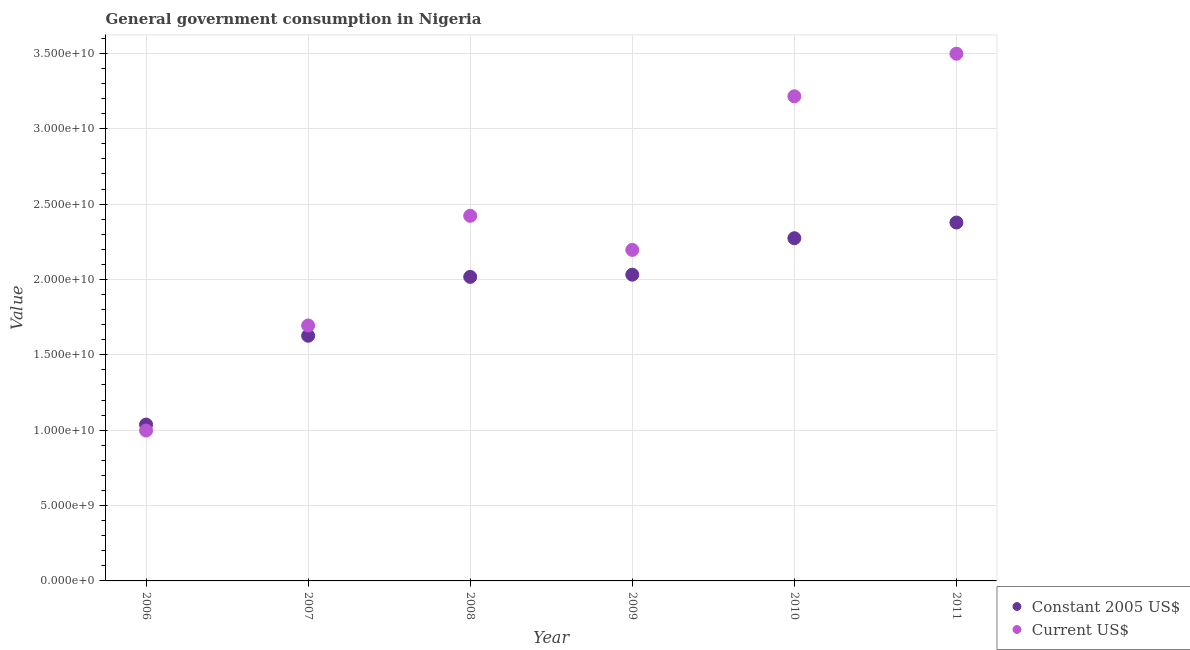Is the number of dotlines equal to the number of legend labels?
Ensure brevity in your answer.  Yes. What is the value consumed in constant 2005 us$ in 2008?
Give a very brief answer. 2.02e+1. Across all years, what is the maximum value consumed in constant 2005 us$?
Keep it short and to the point. 2.38e+1. Across all years, what is the minimum value consumed in constant 2005 us$?
Give a very brief answer. 1.04e+1. In which year was the value consumed in current us$ minimum?
Your answer should be compact. 2006. What is the total value consumed in current us$ in the graph?
Your response must be concise. 1.40e+11. What is the difference between the value consumed in constant 2005 us$ in 2009 and that in 2011?
Provide a succinct answer. -3.46e+09. What is the difference between the value consumed in current us$ in 2006 and the value consumed in constant 2005 us$ in 2009?
Offer a very short reply. -1.03e+1. What is the average value consumed in current us$ per year?
Offer a terse response. 2.34e+1. In the year 2008, what is the difference between the value consumed in constant 2005 us$ and value consumed in current us$?
Your answer should be compact. -4.05e+09. In how many years, is the value consumed in current us$ greater than 22000000000?
Your answer should be very brief. 3. What is the ratio of the value consumed in current us$ in 2006 to that in 2008?
Offer a very short reply. 0.41. Is the difference between the value consumed in constant 2005 us$ in 2009 and 2011 greater than the difference between the value consumed in current us$ in 2009 and 2011?
Give a very brief answer. Yes. What is the difference between the highest and the second highest value consumed in constant 2005 us$?
Make the answer very short. 1.04e+09. What is the difference between the highest and the lowest value consumed in constant 2005 us$?
Your response must be concise. 1.34e+1. Is the value consumed in constant 2005 us$ strictly greater than the value consumed in current us$ over the years?
Keep it short and to the point. No. Is the value consumed in constant 2005 us$ strictly less than the value consumed in current us$ over the years?
Your answer should be very brief. No. Are the values on the major ticks of Y-axis written in scientific E-notation?
Offer a very short reply. Yes. Does the graph contain any zero values?
Your response must be concise. No. What is the title of the graph?
Make the answer very short. General government consumption in Nigeria. Does "Research and Development" appear as one of the legend labels in the graph?
Make the answer very short. No. What is the label or title of the Y-axis?
Keep it short and to the point. Value. What is the Value of Constant 2005 US$ in 2006?
Your response must be concise. 1.04e+1. What is the Value in Current US$ in 2006?
Your answer should be compact. 9.98e+09. What is the Value in Constant 2005 US$ in 2007?
Your answer should be very brief. 1.63e+1. What is the Value of Current US$ in 2007?
Provide a short and direct response. 1.69e+1. What is the Value of Constant 2005 US$ in 2008?
Make the answer very short. 2.02e+1. What is the Value in Current US$ in 2008?
Your answer should be very brief. 2.42e+1. What is the Value in Constant 2005 US$ in 2009?
Keep it short and to the point. 2.03e+1. What is the Value in Current US$ in 2009?
Make the answer very short. 2.20e+1. What is the Value in Constant 2005 US$ in 2010?
Offer a terse response. 2.27e+1. What is the Value in Current US$ in 2010?
Give a very brief answer. 3.22e+1. What is the Value in Constant 2005 US$ in 2011?
Your answer should be very brief. 2.38e+1. What is the Value of Current US$ in 2011?
Provide a short and direct response. 3.50e+1. Across all years, what is the maximum Value in Constant 2005 US$?
Provide a succinct answer. 2.38e+1. Across all years, what is the maximum Value of Current US$?
Give a very brief answer. 3.50e+1. Across all years, what is the minimum Value of Constant 2005 US$?
Keep it short and to the point. 1.04e+1. Across all years, what is the minimum Value of Current US$?
Offer a terse response. 9.98e+09. What is the total Value in Constant 2005 US$ in the graph?
Provide a short and direct response. 1.14e+11. What is the total Value of Current US$ in the graph?
Make the answer very short. 1.40e+11. What is the difference between the Value of Constant 2005 US$ in 2006 and that in 2007?
Your answer should be very brief. -5.89e+09. What is the difference between the Value of Current US$ in 2006 and that in 2007?
Give a very brief answer. -6.97e+09. What is the difference between the Value in Constant 2005 US$ in 2006 and that in 2008?
Provide a short and direct response. -9.80e+09. What is the difference between the Value in Current US$ in 2006 and that in 2008?
Ensure brevity in your answer.  -1.42e+1. What is the difference between the Value of Constant 2005 US$ in 2006 and that in 2009?
Ensure brevity in your answer.  -9.94e+09. What is the difference between the Value in Current US$ in 2006 and that in 2009?
Make the answer very short. -1.20e+1. What is the difference between the Value of Constant 2005 US$ in 2006 and that in 2010?
Your answer should be compact. -1.24e+1. What is the difference between the Value in Current US$ in 2006 and that in 2010?
Your answer should be compact. -2.22e+1. What is the difference between the Value in Constant 2005 US$ in 2006 and that in 2011?
Offer a terse response. -1.34e+1. What is the difference between the Value in Current US$ in 2006 and that in 2011?
Offer a terse response. -2.50e+1. What is the difference between the Value of Constant 2005 US$ in 2007 and that in 2008?
Your answer should be very brief. -3.91e+09. What is the difference between the Value of Current US$ in 2007 and that in 2008?
Offer a terse response. -7.28e+09. What is the difference between the Value in Constant 2005 US$ in 2007 and that in 2009?
Offer a terse response. -4.05e+09. What is the difference between the Value in Current US$ in 2007 and that in 2009?
Ensure brevity in your answer.  -5.02e+09. What is the difference between the Value in Constant 2005 US$ in 2007 and that in 2010?
Offer a very short reply. -6.47e+09. What is the difference between the Value of Current US$ in 2007 and that in 2010?
Give a very brief answer. -1.52e+1. What is the difference between the Value of Constant 2005 US$ in 2007 and that in 2011?
Provide a short and direct response. -7.51e+09. What is the difference between the Value of Current US$ in 2007 and that in 2011?
Your response must be concise. -1.80e+1. What is the difference between the Value in Constant 2005 US$ in 2008 and that in 2009?
Provide a short and direct response. -1.46e+08. What is the difference between the Value in Current US$ in 2008 and that in 2009?
Give a very brief answer. 2.26e+09. What is the difference between the Value in Constant 2005 US$ in 2008 and that in 2010?
Provide a short and direct response. -2.56e+09. What is the difference between the Value of Current US$ in 2008 and that in 2010?
Your answer should be compact. -7.93e+09. What is the difference between the Value in Constant 2005 US$ in 2008 and that in 2011?
Offer a terse response. -3.60e+09. What is the difference between the Value in Current US$ in 2008 and that in 2011?
Your answer should be very brief. -1.08e+1. What is the difference between the Value in Constant 2005 US$ in 2009 and that in 2010?
Your answer should be very brief. -2.42e+09. What is the difference between the Value of Current US$ in 2009 and that in 2010?
Make the answer very short. -1.02e+1. What is the difference between the Value in Constant 2005 US$ in 2009 and that in 2011?
Your answer should be compact. -3.46e+09. What is the difference between the Value in Current US$ in 2009 and that in 2011?
Your response must be concise. -1.30e+1. What is the difference between the Value of Constant 2005 US$ in 2010 and that in 2011?
Keep it short and to the point. -1.04e+09. What is the difference between the Value of Current US$ in 2010 and that in 2011?
Your answer should be very brief. -2.82e+09. What is the difference between the Value of Constant 2005 US$ in 2006 and the Value of Current US$ in 2007?
Make the answer very short. -6.57e+09. What is the difference between the Value of Constant 2005 US$ in 2006 and the Value of Current US$ in 2008?
Your response must be concise. -1.38e+1. What is the difference between the Value in Constant 2005 US$ in 2006 and the Value in Current US$ in 2009?
Ensure brevity in your answer.  -1.16e+1. What is the difference between the Value in Constant 2005 US$ in 2006 and the Value in Current US$ in 2010?
Provide a short and direct response. -2.18e+1. What is the difference between the Value in Constant 2005 US$ in 2006 and the Value in Current US$ in 2011?
Your answer should be very brief. -2.46e+1. What is the difference between the Value of Constant 2005 US$ in 2007 and the Value of Current US$ in 2008?
Offer a terse response. -7.96e+09. What is the difference between the Value of Constant 2005 US$ in 2007 and the Value of Current US$ in 2009?
Offer a very short reply. -5.70e+09. What is the difference between the Value in Constant 2005 US$ in 2007 and the Value in Current US$ in 2010?
Make the answer very short. -1.59e+1. What is the difference between the Value in Constant 2005 US$ in 2007 and the Value in Current US$ in 2011?
Make the answer very short. -1.87e+1. What is the difference between the Value in Constant 2005 US$ in 2008 and the Value in Current US$ in 2009?
Your answer should be very brief. -1.79e+09. What is the difference between the Value in Constant 2005 US$ in 2008 and the Value in Current US$ in 2010?
Keep it short and to the point. -1.20e+1. What is the difference between the Value of Constant 2005 US$ in 2008 and the Value of Current US$ in 2011?
Your answer should be very brief. -1.48e+1. What is the difference between the Value in Constant 2005 US$ in 2009 and the Value in Current US$ in 2010?
Offer a terse response. -1.18e+1. What is the difference between the Value in Constant 2005 US$ in 2009 and the Value in Current US$ in 2011?
Offer a very short reply. -1.47e+1. What is the difference between the Value in Constant 2005 US$ in 2010 and the Value in Current US$ in 2011?
Your response must be concise. -1.22e+1. What is the average Value of Constant 2005 US$ per year?
Your response must be concise. 1.89e+1. What is the average Value of Current US$ per year?
Provide a short and direct response. 2.34e+1. In the year 2006, what is the difference between the Value in Constant 2005 US$ and Value in Current US$?
Offer a very short reply. 3.97e+08. In the year 2007, what is the difference between the Value in Constant 2005 US$ and Value in Current US$?
Provide a succinct answer. -6.80e+08. In the year 2008, what is the difference between the Value of Constant 2005 US$ and Value of Current US$?
Give a very brief answer. -4.05e+09. In the year 2009, what is the difference between the Value in Constant 2005 US$ and Value in Current US$?
Ensure brevity in your answer.  -1.64e+09. In the year 2010, what is the difference between the Value in Constant 2005 US$ and Value in Current US$?
Your response must be concise. -9.41e+09. In the year 2011, what is the difference between the Value in Constant 2005 US$ and Value in Current US$?
Offer a terse response. -1.12e+1. What is the ratio of the Value in Constant 2005 US$ in 2006 to that in 2007?
Give a very brief answer. 0.64. What is the ratio of the Value in Current US$ in 2006 to that in 2007?
Your answer should be compact. 0.59. What is the ratio of the Value in Constant 2005 US$ in 2006 to that in 2008?
Make the answer very short. 0.51. What is the ratio of the Value in Current US$ in 2006 to that in 2008?
Offer a terse response. 0.41. What is the ratio of the Value of Constant 2005 US$ in 2006 to that in 2009?
Your answer should be compact. 0.51. What is the ratio of the Value in Current US$ in 2006 to that in 2009?
Your answer should be very brief. 0.45. What is the ratio of the Value of Constant 2005 US$ in 2006 to that in 2010?
Your response must be concise. 0.46. What is the ratio of the Value of Current US$ in 2006 to that in 2010?
Provide a succinct answer. 0.31. What is the ratio of the Value in Constant 2005 US$ in 2006 to that in 2011?
Offer a very short reply. 0.44. What is the ratio of the Value in Current US$ in 2006 to that in 2011?
Your response must be concise. 0.29. What is the ratio of the Value in Constant 2005 US$ in 2007 to that in 2008?
Your response must be concise. 0.81. What is the ratio of the Value in Current US$ in 2007 to that in 2008?
Give a very brief answer. 0.7. What is the ratio of the Value in Constant 2005 US$ in 2007 to that in 2009?
Make the answer very short. 0.8. What is the ratio of the Value of Current US$ in 2007 to that in 2009?
Ensure brevity in your answer.  0.77. What is the ratio of the Value of Constant 2005 US$ in 2007 to that in 2010?
Your response must be concise. 0.72. What is the ratio of the Value in Current US$ in 2007 to that in 2010?
Your answer should be compact. 0.53. What is the ratio of the Value in Constant 2005 US$ in 2007 to that in 2011?
Your answer should be very brief. 0.68. What is the ratio of the Value of Current US$ in 2007 to that in 2011?
Offer a terse response. 0.48. What is the ratio of the Value in Constant 2005 US$ in 2008 to that in 2009?
Keep it short and to the point. 0.99. What is the ratio of the Value of Current US$ in 2008 to that in 2009?
Give a very brief answer. 1.1. What is the ratio of the Value in Constant 2005 US$ in 2008 to that in 2010?
Provide a succinct answer. 0.89. What is the ratio of the Value in Current US$ in 2008 to that in 2010?
Offer a terse response. 0.75. What is the ratio of the Value of Constant 2005 US$ in 2008 to that in 2011?
Keep it short and to the point. 0.85. What is the ratio of the Value of Current US$ in 2008 to that in 2011?
Provide a short and direct response. 0.69. What is the ratio of the Value in Constant 2005 US$ in 2009 to that in 2010?
Keep it short and to the point. 0.89. What is the ratio of the Value of Current US$ in 2009 to that in 2010?
Your answer should be very brief. 0.68. What is the ratio of the Value of Constant 2005 US$ in 2009 to that in 2011?
Give a very brief answer. 0.85. What is the ratio of the Value in Current US$ in 2009 to that in 2011?
Keep it short and to the point. 0.63. What is the ratio of the Value in Constant 2005 US$ in 2010 to that in 2011?
Ensure brevity in your answer.  0.96. What is the ratio of the Value in Current US$ in 2010 to that in 2011?
Ensure brevity in your answer.  0.92. What is the difference between the highest and the second highest Value in Constant 2005 US$?
Keep it short and to the point. 1.04e+09. What is the difference between the highest and the second highest Value in Current US$?
Keep it short and to the point. 2.82e+09. What is the difference between the highest and the lowest Value of Constant 2005 US$?
Provide a short and direct response. 1.34e+1. What is the difference between the highest and the lowest Value of Current US$?
Keep it short and to the point. 2.50e+1. 